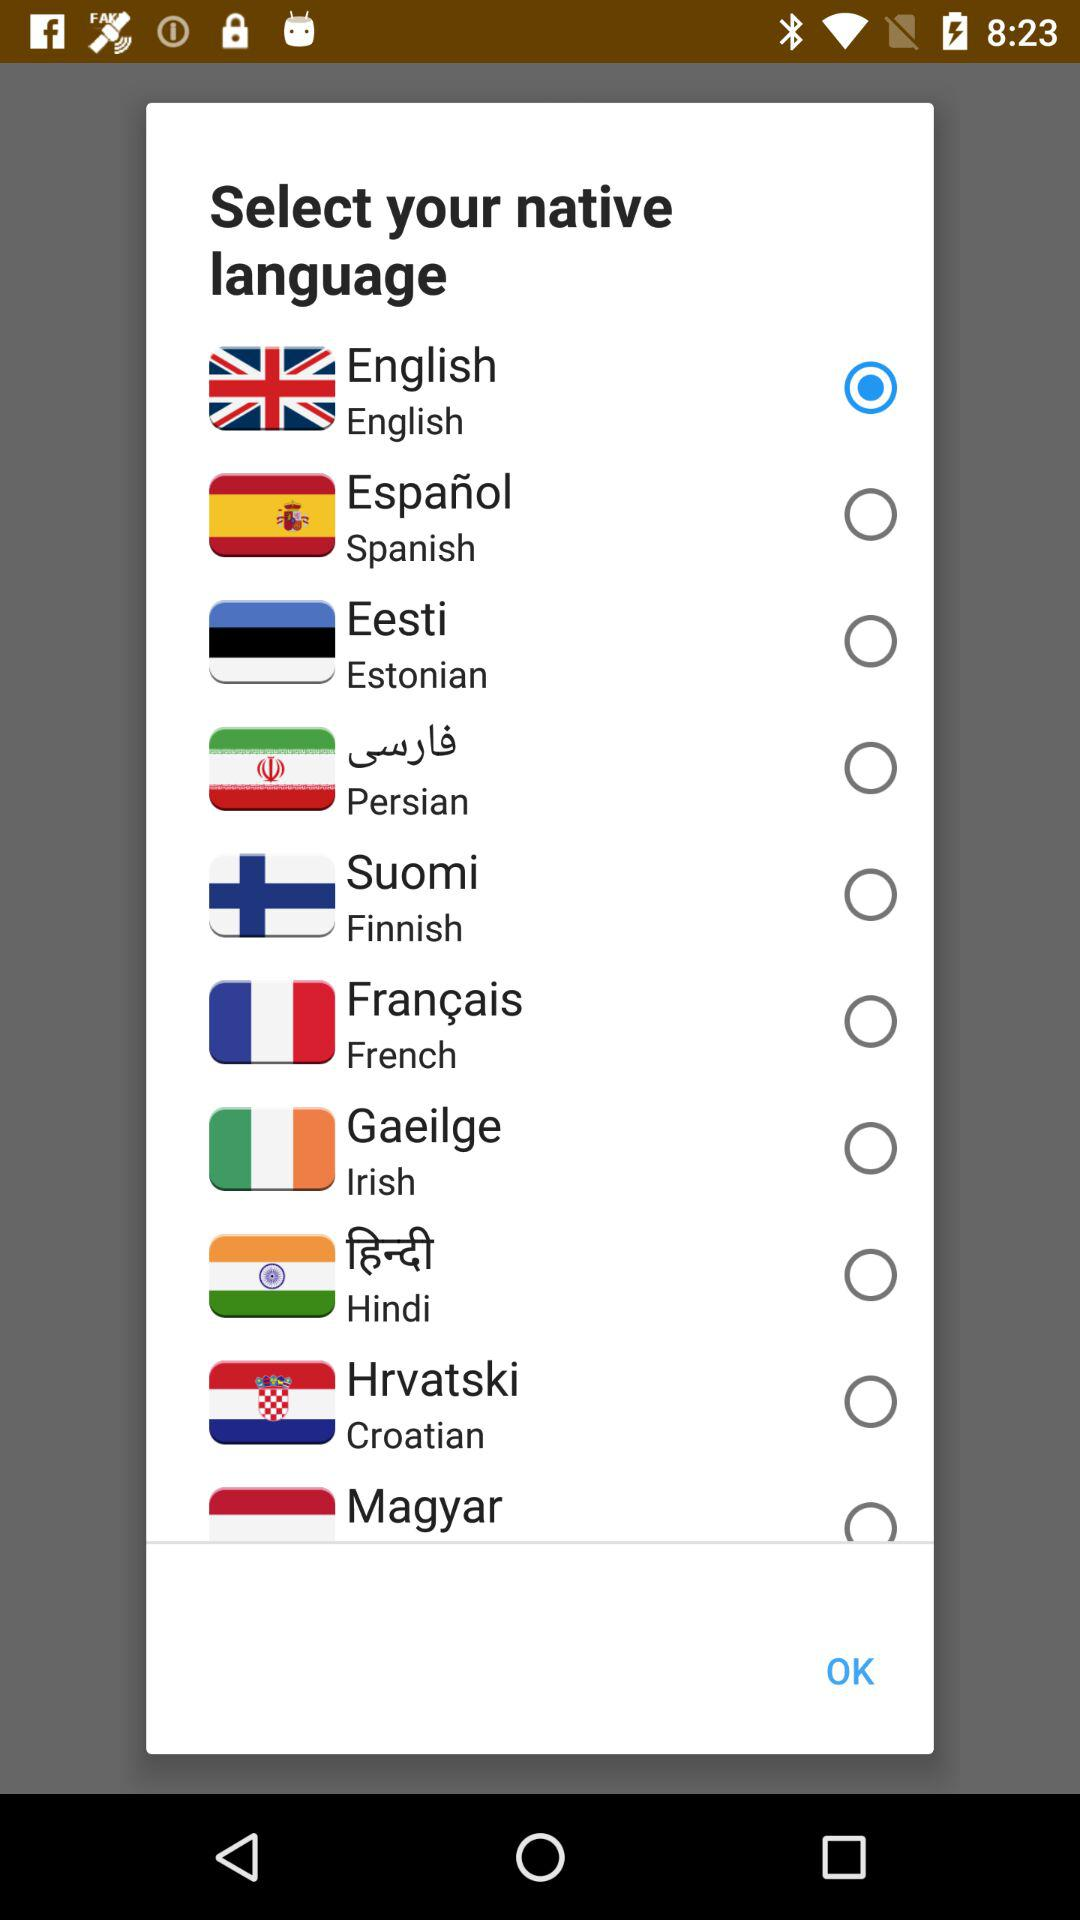Which language has been selected? The language that has been selected is English. 